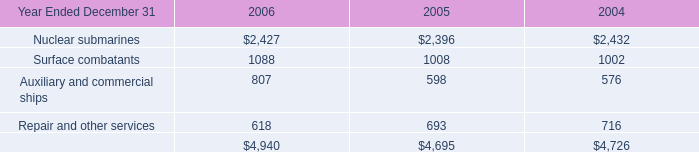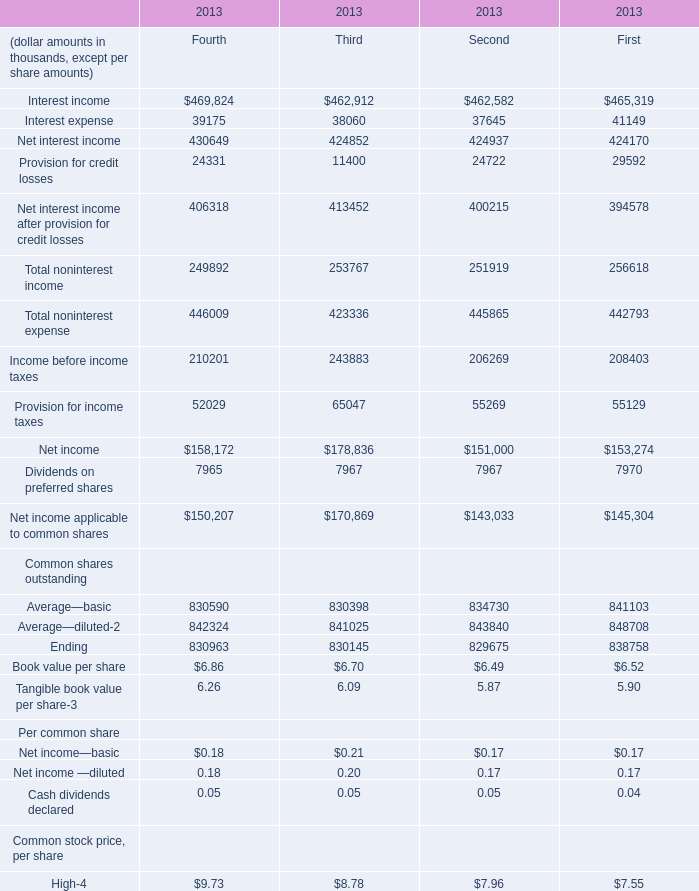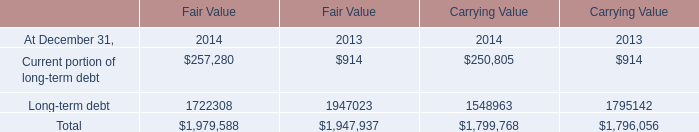What is the total amount of Net income applicable to common shares of 2013 Third, Nuclear submarines of 2005, and Total of Carrying Value 2014 ? 
Computations: ((170869.0 + 2396.0) + 1799768.0)
Answer: 1973033.0. 